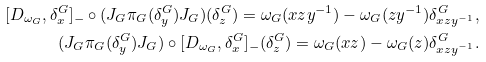Convert formula to latex. <formula><loc_0><loc_0><loc_500><loc_500>[ D _ { \omega _ { G } } , \delta _ { x } ^ { G } ] _ { - } \circ ( J _ { G } \pi _ { G } ( \delta _ { y } ^ { G } ) J _ { G } ) ( \delta _ { z } ^ { G } ) = \omega _ { G } ( x z y ^ { - 1 } ) - \omega _ { G } ( z y ^ { - 1 } ) \delta ^ { G } _ { x z y ^ { - 1 } } , \\ ( J _ { G } \pi _ { G } ( \delta _ { y } ^ { G } ) J _ { G } ) \circ [ D _ { \omega _ { G } } , \delta _ { x } ^ { G } ] _ { - } ( \delta _ { z } ^ { G } ) = \omega _ { G } ( x z ) - \omega _ { G } ( z ) \delta ^ { G } _ { x z y ^ { - 1 } } .</formula> 